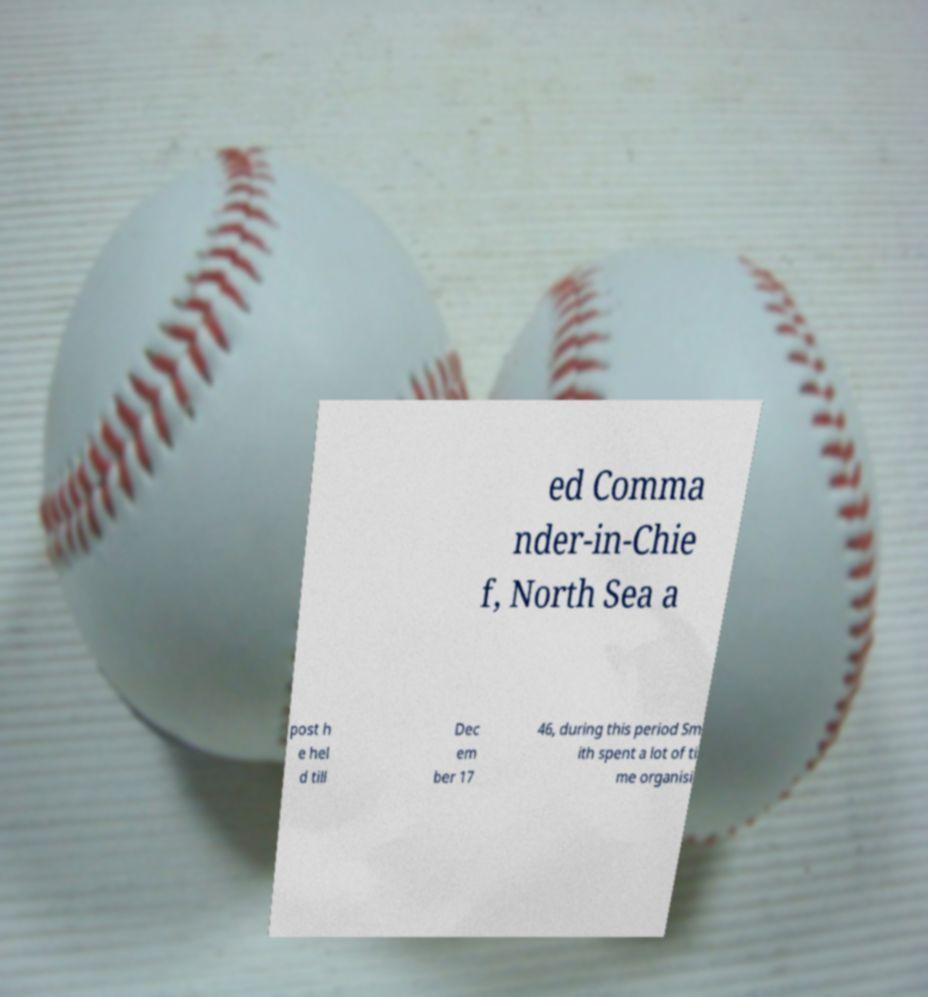I need the written content from this picture converted into text. Can you do that? ed Comma nder-in-Chie f, North Sea a post h e hel d till Dec em ber 17 46, during this period Sm ith spent a lot of ti me organisi 